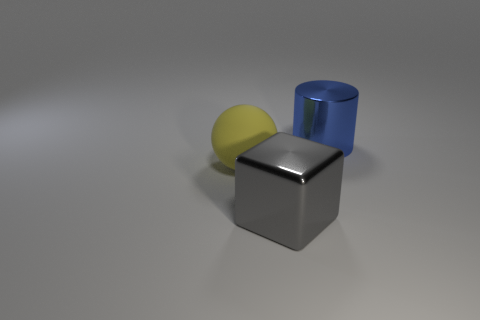Do the large thing behind the large ball and the gray metal object have the same shape? no 